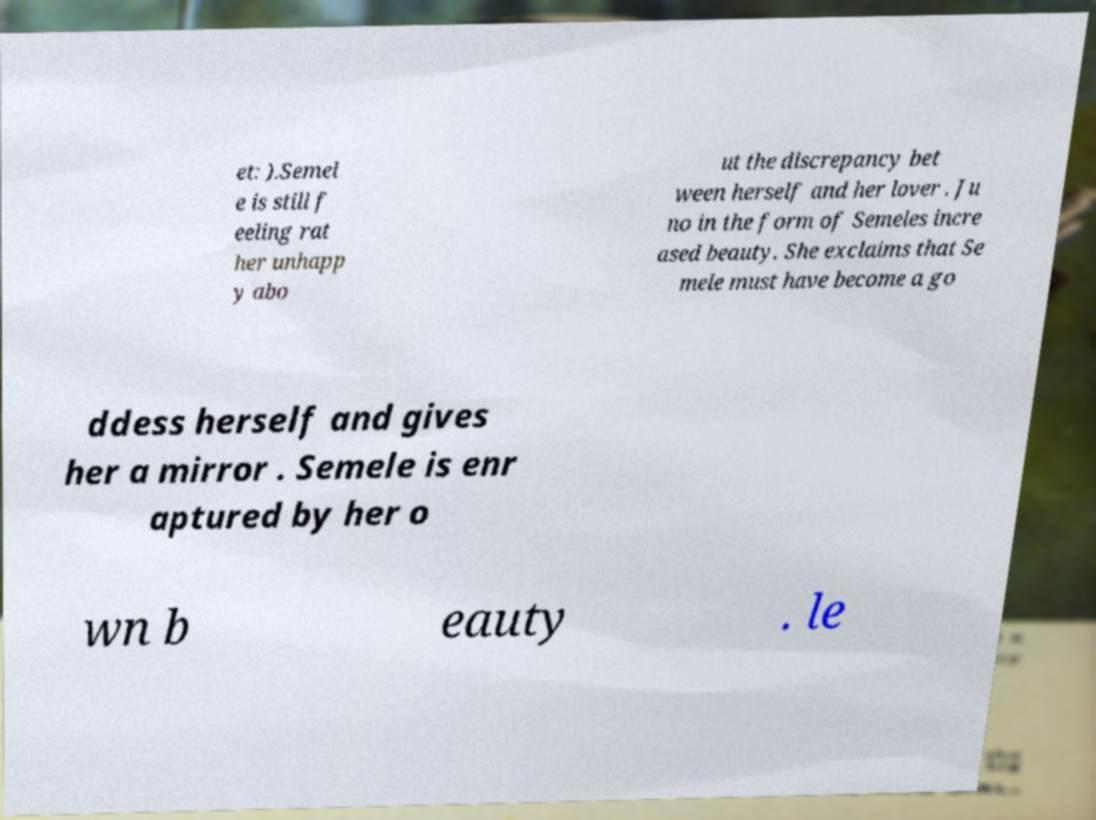Can you read and provide the text displayed in the image?This photo seems to have some interesting text. Can you extract and type it out for me? et: ).Semel e is still f eeling rat her unhapp y abo ut the discrepancy bet ween herself and her lover . Ju no in the form of Semeles incre ased beauty. She exclaims that Se mele must have become a go ddess herself and gives her a mirror . Semele is enr aptured by her o wn b eauty . le 